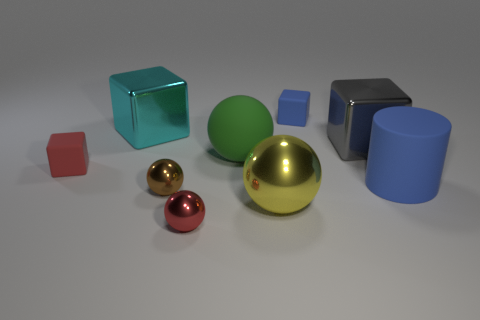Subtract 1 blocks. How many blocks are left? 3 Subtract all metal spheres. How many spheres are left? 1 Add 1 small blue matte things. How many objects exist? 10 Subtract all purple balls. Subtract all brown cylinders. How many balls are left? 4 Add 4 tiny objects. How many tiny objects exist? 8 Subtract 0 yellow blocks. How many objects are left? 9 Subtract all cylinders. How many objects are left? 8 Subtract all big yellow metallic objects. Subtract all tiny shiny objects. How many objects are left? 6 Add 8 gray metal things. How many gray metal things are left? 9 